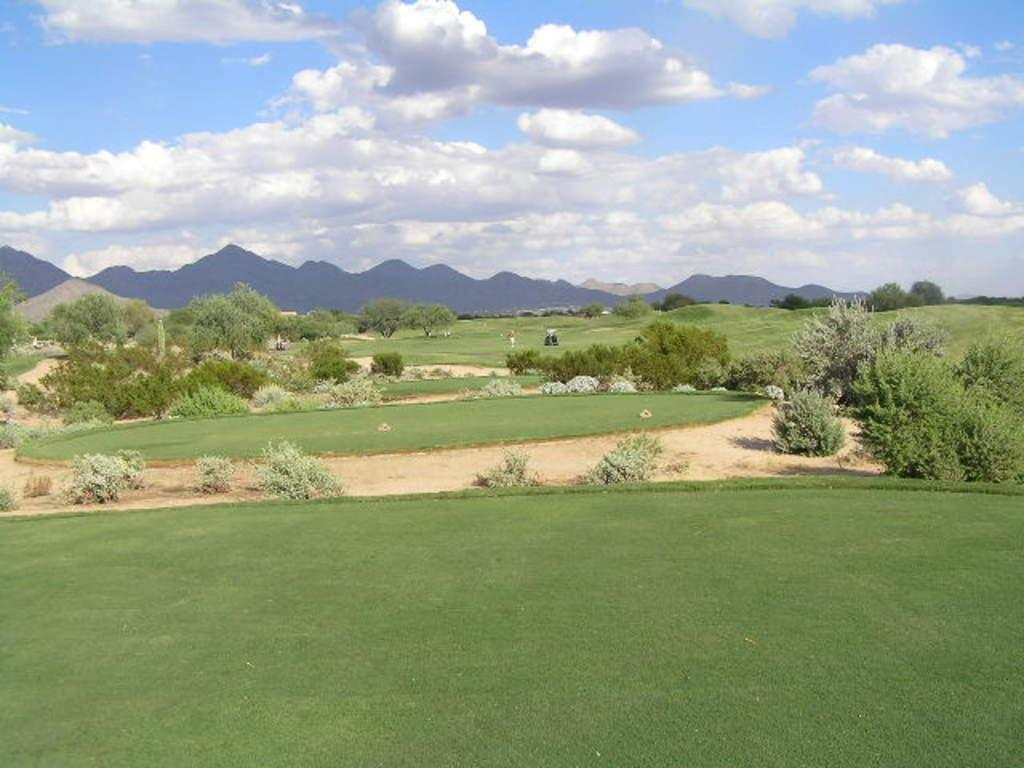What type of vegetation can be seen in the image? There is grass, plants, and trees visible in the image. What else is present in the image besides vegetation? There is a vehicle in the image. What can be seen in the background of the image? Hills and the sky are visible in the background of the image. What is the condition of the sky in the image? Clouds are present in the sky. What type of spade is being used to dig up the existence of the whip in the image? There is no spade, existence, or whip present in the image. 